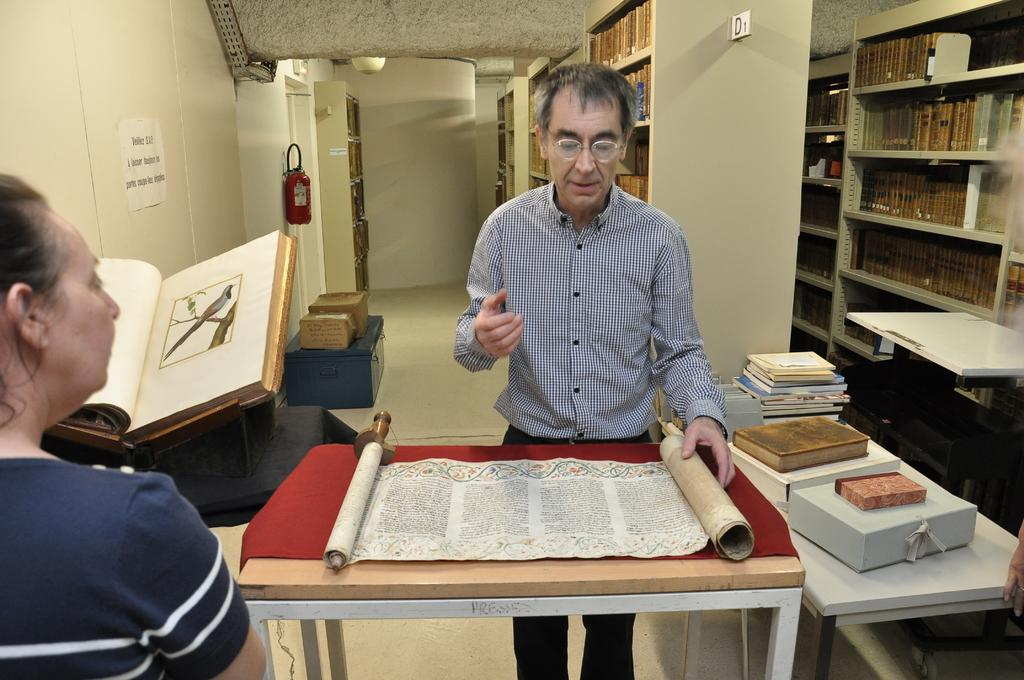How many people are present in the image? There is a man and a woman present in the image. What objects can be seen on the table in the image? There is a scroll and a book on the table. Can you describe the background of the image? The background of the image shows multiple books. What type of mailbox can be seen in the image? There is no mailbox present in the image. What is the name of the governor in the image? There is no governor present in the image. 